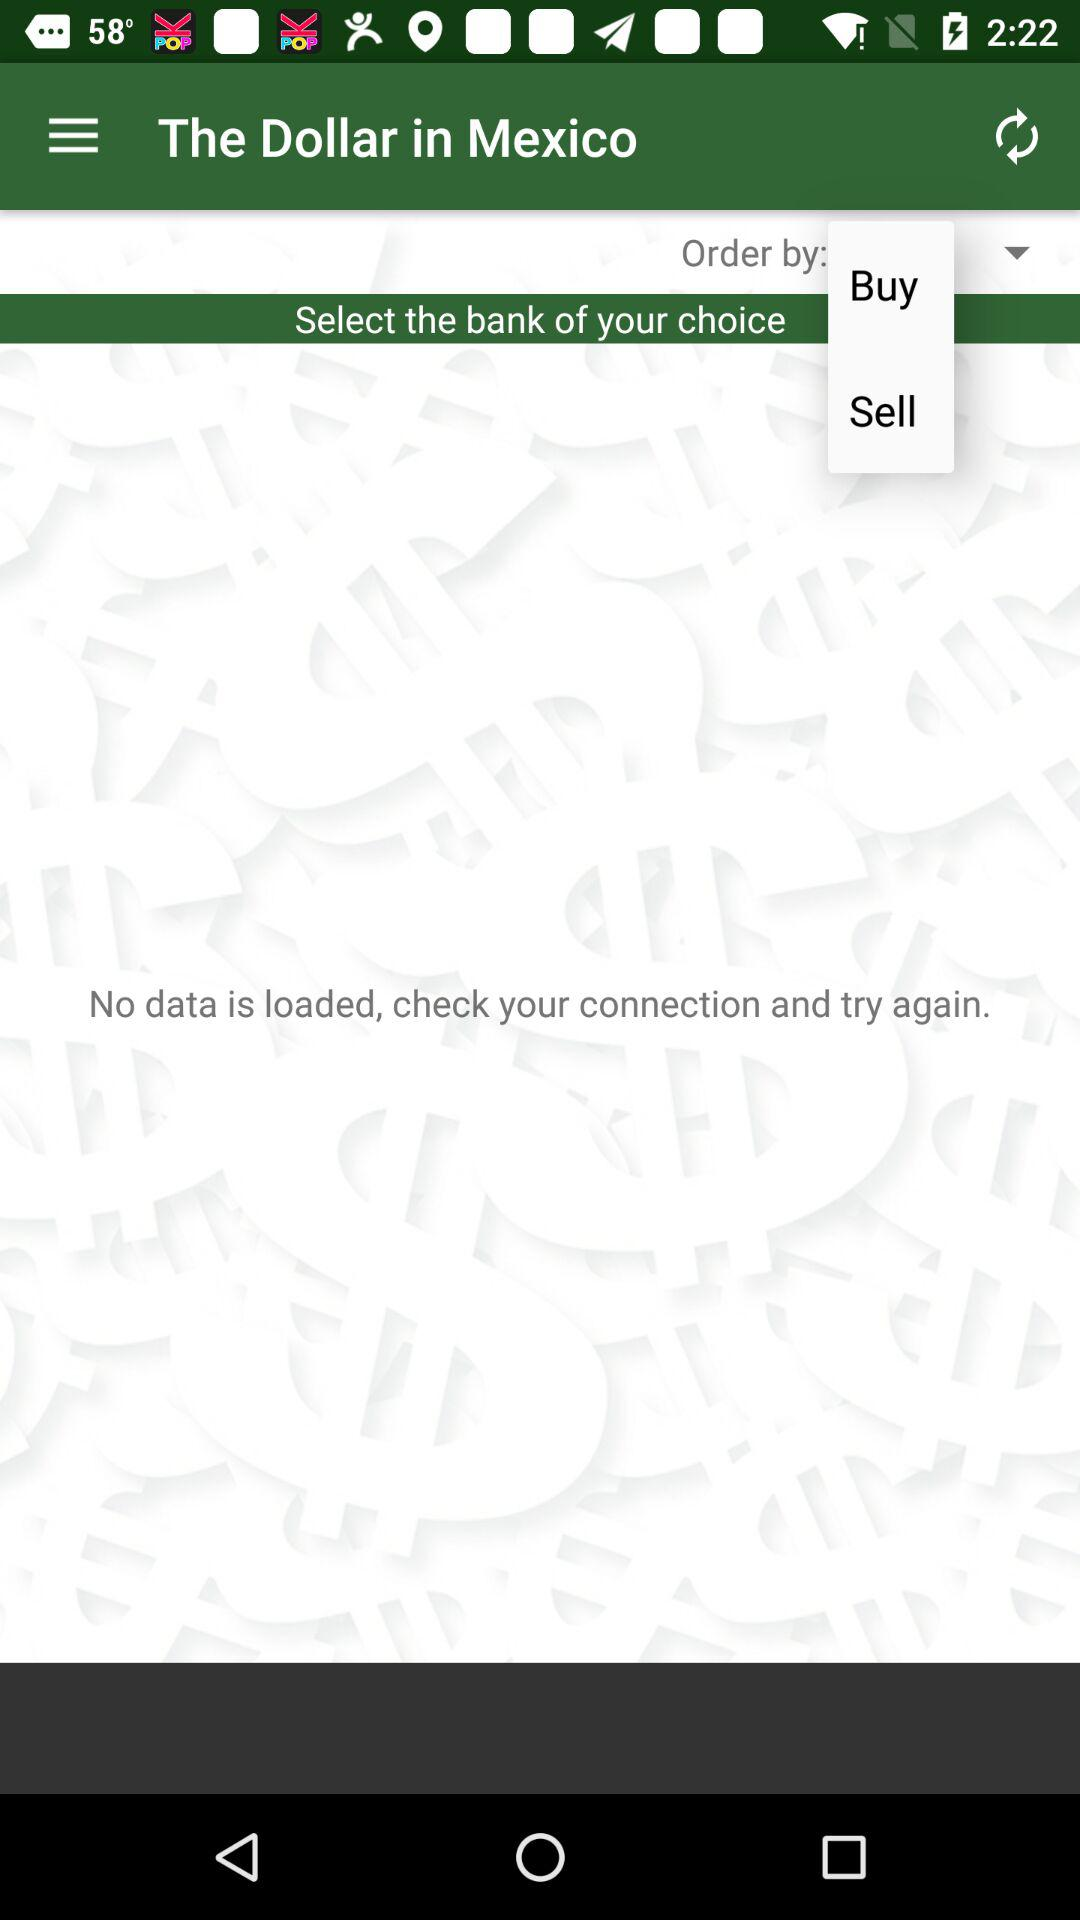What is the application name? The application name is "The Dollar in Mexico". 